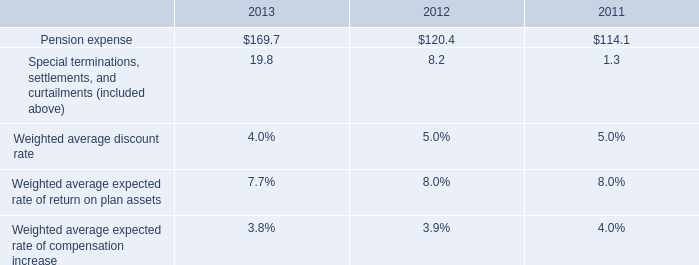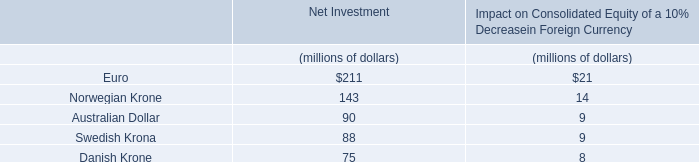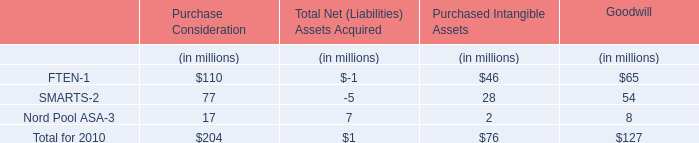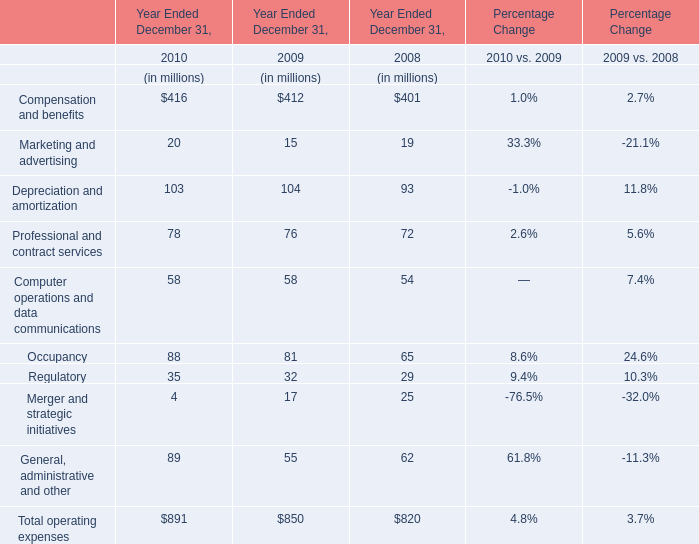What is the sum of Marketing and advertising and Professional and contract services in 2010 ? (in million) 
Computations: (20 + 78)
Answer: 98.0. 